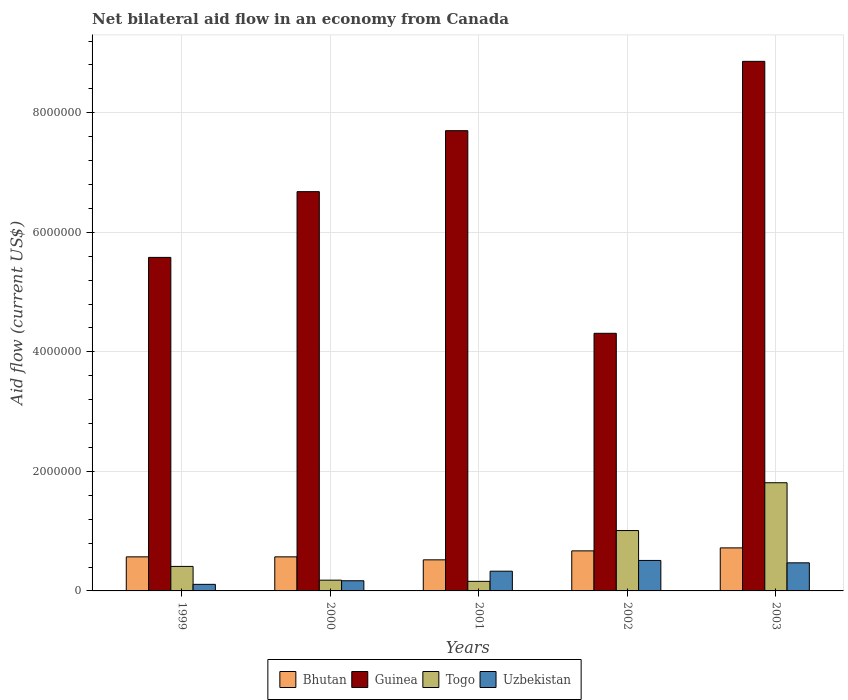How many groups of bars are there?
Offer a terse response. 5. What is the net bilateral aid flow in Bhutan in 2003?
Give a very brief answer. 7.20e+05. Across all years, what is the maximum net bilateral aid flow in Bhutan?
Keep it short and to the point. 7.20e+05. In which year was the net bilateral aid flow in Guinea maximum?
Keep it short and to the point. 2003. What is the total net bilateral aid flow in Guinea in the graph?
Provide a short and direct response. 3.31e+07. What is the difference between the net bilateral aid flow in Bhutan in 1999 and that in 2003?
Keep it short and to the point. -1.50e+05. What is the difference between the net bilateral aid flow in Guinea in 2003 and the net bilateral aid flow in Togo in 1999?
Make the answer very short. 8.45e+06. What is the average net bilateral aid flow in Guinea per year?
Offer a very short reply. 6.63e+06. In the year 2003, what is the difference between the net bilateral aid flow in Uzbekistan and net bilateral aid flow in Guinea?
Your response must be concise. -8.39e+06. In how many years, is the net bilateral aid flow in Guinea greater than 6400000 US$?
Keep it short and to the point. 3. What is the ratio of the net bilateral aid flow in Bhutan in 2000 to that in 2002?
Offer a terse response. 0.85. Is the difference between the net bilateral aid flow in Uzbekistan in 2002 and 2003 greater than the difference between the net bilateral aid flow in Guinea in 2002 and 2003?
Provide a short and direct response. Yes. What is the difference between the highest and the lowest net bilateral aid flow in Guinea?
Ensure brevity in your answer.  4.55e+06. In how many years, is the net bilateral aid flow in Togo greater than the average net bilateral aid flow in Togo taken over all years?
Offer a very short reply. 2. Is the sum of the net bilateral aid flow in Uzbekistan in 1999 and 2000 greater than the maximum net bilateral aid flow in Guinea across all years?
Offer a terse response. No. What does the 4th bar from the left in 2001 represents?
Offer a very short reply. Uzbekistan. What does the 1st bar from the right in 1999 represents?
Keep it short and to the point. Uzbekistan. Is it the case that in every year, the sum of the net bilateral aid flow in Bhutan and net bilateral aid flow in Togo is greater than the net bilateral aid flow in Uzbekistan?
Offer a terse response. Yes. Are all the bars in the graph horizontal?
Your answer should be very brief. No. How many years are there in the graph?
Keep it short and to the point. 5. What is the difference between two consecutive major ticks on the Y-axis?
Your answer should be compact. 2.00e+06. What is the title of the graph?
Your answer should be compact. Net bilateral aid flow in an economy from Canada. What is the Aid flow (current US$) in Bhutan in 1999?
Offer a terse response. 5.70e+05. What is the Aid flow (current US$) in Guinea in 1999?
Your response must be concise. 5.58e+06. What is the Aid flow (current US$) of Bhutan in 2000?
Your response must be concise. 5.70e+05. What is the Aid flow (current US$) of Guinea in 2000?
Provide a succinct answer. 6.68e+06. What is the Aid flow (current US$) in Togo in 2000?
Keep it short and to the point. 1.80e+05. What is the Aid flow (current US$) in Uzbekistan in 2000?
Give a very brief answer. 1.70e+05. What is the Aid flow (current US$) in Bhutan in 2001?
Your answer should be very brief. 5.20e+05. What is the Aid flow (current US$) of Guinea in 2001?
Offer a very short reply. 7.70e+06. What is the Aid flow (current US$) of Togo in 2001?
Offer a very short reply. 1.60e+05. What is the Aid flow (current US$) in Uzbekistan in 2001?
Provide a succinct answer. 3.30e+05. What is the Aid flow (current US$) of Bhutan in 2002?
Offer a very short reply. 6.70e+05. What is the Aid flow (current US$) in Guinea in 2002?
Offer a very short reply. 4.31e+06. What is the Aid flow (current US$) of Togo in 2002?
Make the answer very short. 1.01e+06. What is the Aid flow (current US$) of Uzbekistan in 2002?
Give a very brief answer. 5.10e+05. What is the Aid flow (current US$) of Bhutan in 2003?
Provide a short and direct response. 7.20e+05. What is the Aid flow (current US$) in Guinea in 2003?
Make the answer very short. 8.86e+06. What is the Aid flow (current US$) in Togo in 2003?
Your response must be concise. 1.81e+06. What is the Aid flow (current US$) in Uzbekistan in 2003?
Offer a very short reply. 4.70e+05. Across all years, what is the maximum Aid flow (current US$) in Bhutan?
Provide a short and direct response. 7.20e+05. Across all years, what is the maximum Aid flow (current US$) of Guinea?
Your response must be concise. 8.86e+06. Across all years, what is the maximum Aid flow (current US$) in Togo?
Provide a short and direct response. 1.81e+06. Across all years, what is the maximum Aid flow (current US$) of Uzbekistan?
Keep it short and to the point. 5.10e+05. Across all years, what is the minimum Aid flow (current US$) of Bhutan?
Give a very brief answer. 5.20e+05. Across all years, what is the minimum Aid flow (current US$) in Guinea?
Give a very brief answer. 4.31e+06. What is the total Aid flow (current US$) in Bhutan in the graph?
Provide a short and direct response. 3.05e+06. What is the total Aid flow (current US$) of Guinea in the graph?
Offer a terse response. 3.31e+07. What is the total Aid flow (current US$) in Togo in the graph?
Make the answer very short. 3.57e+06. What is the total Aid flow (current US$) of Uzbekistan in the graph?
Your answer should be very brief. 1.59e+06. What is the difference between the Aid flow (current US$) of Guinea in 1999 and that in 2000?
Offer a very short reply. -1.10e+06. What is the difference between the Aid flow (current US$) in Togo in 1999 and that in 2000?
Give a very brief answer. 2.30e+05. What is the difference between the Aid flow (current US$) in Guinea in 1999 and that in 2001?
Offer a very short reply. -2.12e+06. What is the difference between the Aid flow (current US$) of Togo in 1999 and that in 2001?
Ensure brevity in your answer.  2.50e+05. What is the difference between the Aid flow (current US$) of Guinea in 1999 and that in 2002?
Make the answer very short. 1.27e+06. What is the difference between the Aid flow (current US$) in Togo in 1999 and that in 2002?
Your answer should be compact. -6.00e+05. What is the difference between the Aid flow (current US$) in Uzbekistan in 1999 and that in 2002?
Your answer should be very brief. -4.00e+05. What is the difference between the Aid flow (current US$) of Bhutan in 1999 and that in 2003?
Keep it short and to the point. -1.50e+05. What is the difference between the Aid flow (current US$) in Guinea in 1999 and that in 2003?
Offer a very short reply. -3.28e+06. What is the difference between the Aid flow (current US$) in Togo in 1999 and that in 2003?
Keep it short and to the point. -1.40e+06. What is the difference between the Aid flow (current US$) of Uzbekistan in 1999 and that in 2003?
Offer a terse response. -3.60e+05. What is the difference between the Aid flow (current US$) in Bhutan in 2000 and that in 2001?
Ensure brevity in your answer.  5.00e+04. What is the difference between the Aid flow (current US$) of Guinea in 2000 and that in 2001?
Keep it short and to the point. -1.02e+06. What is the difference between the Aid flow (current US$) of Guinea in 2000 and that in 2002?
Provide a short and direct response. 2.37e+06. What is the difference between the Aid flow (current US$) of Togo in 2000 and that in 2002?
Your response must be concise. -8.30e+05. What is the difference between the Aid flow (current US$) of Uzbekistan in 2000 and that in 2002?
Offer a terse response. -3.40e+05. What is the difference between the Aid flow (current US$) in Guinea in 2000 and that in 2003?
Keep it short and to the point. -2.18e+06. What is the difference between the Aid flow (current US$) of Togo in 2000 and that in 2003?
Offer a very short reply. -1.63e+06. What is the difference between the Aid flow (current US$) of Uzbekistan in 2000 and that in 2003?
Offer a very short reply. -3.00e+05. What is the difference between the Aid flow (current US$) in Bhutan in 2001 and that in 2002?
Keep it short and to the point. -1.50e+05. What is the difference between the Aid flow (current US$) in Guinea in 2001 and that in 2002?
Your answer should be very brief. 3.39e+06. What is the difference between the Aid flow (current US$) of Togo in 2001 and that in 2002?
Your answer should be compact. -8.50e+05. What is the difference between the Aid flow (current US$) in Uzbekistan in 2001 and that in 2002?
Make the answer very short. -1.80e+05. What is the difference between the Aid flow (current US$) of Guinea in 2001 and that in 2003?
Make the answer very short. -1.16e+06. What is the difference between the Aid flow (current US$) in Togo in 2001 and that in 2003?
Offer a terse response. -1.65e+06. What is the difference between the Aid flow (current US$) of Uzbekistan in 2001 and that in 2003?
Ensure brevity in your answer.  -1.40e+05. What is the difference between the Aid flow (current US$) in Guinea in 2002 and that in 2003?
Your response must be concise. -4.55e+06. What is the difference between the Aid flow (current US$) of Togo in 2002 and that in 2003?
Your answer should be very brief. -8.00e+05. What is the difference between the Aid flow (current US$) in Bhutan in 1999 and the Aid flow (current US$) in Guinea in 2000?
Give a very brief answer. -6.11e+06. What is the difference between the Aid flow (current US$) in Bhutan in 1999 and the Aid flow (current US$) in Togo in 2000?
Your answer should be very brief. 3.90e+05. What is the difference between the Aid flow (current US$) of Bhutan in 1999 and the Aid flow (current US$) of Uzbekistan in 2000?
Your answer should be compact. 4.00e+05. What is the difference between the Aid flow (current US$) in Guinea in 1999 and the Aid flow (current US$) in Togo in 2000?
Your answer should be compact. 5.40e+06. What is the difference between the Aid flow (current US$) of Guinea in 1999 and the Aid flow (current US$) of Uzbekistan in 2000?
Give a very brief answer. 5.41e+06. What is the difference between the Aid flow (current US$) in Togo in 1999 and the Aid flow (current US$) in Uzbekistan in 2000?
Provide a succinct answer. 2.40e+05. What is the difference between the Aid flow (current US$) in Bhutan in 1999 and the Aid flow (current US$) in Guinea in 2001?
Your response must be concise. -7.13e+06. What is the difference between the Aid flow (current US$) in Bhutan in 1999 and the Aid flow (current US$) in Uzbekistan in 2001?
Provide a short and direct response. 2.40e+05. What is the difference between the Aid flow (current US$) in Guinea in 1999 and the Aid flow (current US$) in Togo in 2001?
Your answer should be very brief. 5.42e+06. What is the difference between the Aid flow (current US$) in Guinea in 1999 and the Aid flow (current US$) in Uzbekistan in 2001?
Offer a very short reply. 5.25e+06. What is the difference between the Aid flow (current US$) in Togo in 1999 and the Aid flow (current US$) in Uzbekistan in 2001?
Ensure brevity in your answer.  8.00e+04. What is the difference between the Aid flow (current US$) in Bhutan in 1999 and the Aid flow (current US$) in Guinea in 2002?
Your answer should be very brief. -3.74e+06. What is the difference between the Aid flow (current US$) in Bhutan in 1999 and the Aid flow (current US$) in Togo in 2002?
Your response must be concise. -4.40e+05. What is the difference between the Aid flow (current US$) in Guinea in 1999 and the Aid flow (current US$) in Togo in 2002?
Your answer should be very brief. 4.57e+06. What is the difference between the Aid flow (current US$) of Guinea in 1999 and the Aid flow (current US$) of Uzbekistan in 2002?
Offer a very short reply. 5.07e+06. What is the difference between the Aid flow (current US$) in Bhutan in 1999 and the Aid flow (current US$) in Guinea in 2003?
Offer a terse response. -8.29e+06. What is the difference between the Aid flow (current US$) in Bhutan in 1999 and the Aid flow (current US$) in Togo in 2003?
Offer a terse response. -1.24e+06. What is the difference between the Aid flow (current US$) in Guinea in 1999 and the Aid flow (current US$) in Togo in 2003?
Provide a short and direct response. 3.77e+06. What is the difference between the Aid flow (current US$) of Guinea in 1999 and the Aid flow (current US$) of Uzbekistan in 2003?
Offer a very short reply. 5.11e+06. What is the difference between the Aid flow (current US$) in Togo in 1999 and the Aid flow (current US$) in Uzbekistan in 2003?
Your answer should be very brief. -6.00e+04. What is the difference between the Aid flow (current US$) of Bhutan in 2000 and the Aid flow (current US$) of Guinea in 2001?
Give a very brief answer. -7.13e+06. What is the difference between the Aid flow (current US$) in Bhutan in 2000 and the Aid flow (current US$) in Togo in 2001?
Offer a terse response. 4.10e+05. What is the difference between the Aid flow (current US$) in Bhutan in 2000 and the Aid flow (current US$) in Uzbekistan in 2001?
Provide a short and direct response. 2.40e+05. What is the difference between the Aid flow (current US$) of Guinea in 2000 and the Aid flow (current US$) of Togo in 2001?
Your response must be concise. 6.52e+06. What is the difference between the Aid flow (current US$) in Guinea in 2000 and the Aid flow (current US$) in Uzbekistan in 2001?
Offer a very short reply. 6.35e+06. What is the difference between the Aid flow (current US$) of Togo in 2000 and the Aid flow (current US$) of Uzbekistan in 2001?
Offer a terse response. -1.50e+05. What is the difference between the Aid flow (current US$) in Bhutan in 2000 and the Aid flow (current US$) in Guinea in 2002?
Keep it short and to the point. -3.74e+06. What is the difference between the Aid flow (current US$) in Bhutan in 2000 and the Aid flow (current US$) in Togo in 2002?
Your answer should be very brief. -4.40e+05. What is the difference between the Aid flow (current US$) of Bhutan in 2000 and the Aid flow (current US$) of Uzbekistan in 2002?
Offer a terse response. 6.00e+04. What is the difference between the Aid flow (current US$) of Guinea in 2000 and the Aid flow (current US$) of Togo in 2002?
Make the answer very short. 5.67e+06. What is the difference between the Aid flow (current US$) in Guinea in 2000 and the Aid flow (current US$) in Uzbekistan in 2002?
Give a very brief answer. 6.17e+06. What is the difference between the Aid flow (current US$) of Togo in 2000 and the Aid flow (current US$) of Uzbekistan in 2002?
Your answer should be very brief. -3.30e+05. What is the difference between the Aid flow (current US$) of Bhutan in 2000 and the Aid flow (current US$) of Guinea in 2003?
Give a very brief answer. -8.29e+06. What is the difference between the Aid flow (current US$) in Bhutan in 2000 and the Aid flow (current US$) in Togo in 2003?
Make the answer very short. -1.24e+06. What is the difference between the Aid flow (current US$) in Guinea in 2000 and the Aid flow (current US$) in Togo in 2003?
Give a very brief answer. 4.87e+06. What is the difference between the Aid flow (current US$) in Guinea in 2000 and the Aid flow (current US$) in Uzbekistan in 2003?
Offer a terse response. 6.21e+06. What is the difference between the Aid flow (current US$) of Bhutan in 2001 and the Aid flow (current US$) of Guinea in 2002?
Your answer should be very brief. -3.79e+06. What is the difference between the Aid flow (current US$) in Bhutan in 2001 and the Aid flow (current US$) in Togo in 2002?
Ensure brevity in your answer.  -4.90e+05. What is the difference between the Aid flow (current US$) in Guinea in 2001 and the Aid flow (current US$) in Togo in 2002?
Provide a short and direct response. 6.69e+06. What is the difference between the Aid flow (current US$) of Guinea in 2001 and the Aid flow (current US$) of Uzbekistan in 2002?
Give a very brief answer. 7.19e+06. What is the difference between the Aid flow (current US$) of Togo in 2001 and the Aid flow (current US$) of Uzbekistan in 2002?
Provide a succinct answer. -3.50e+05. What is the difference between the Aid flow (current US$) in Bhutan in 2001 and the Aid flow (current US$) in Guinea in 2003?
Provide a short and direct response. -8.34e+06. What is the difference between the Aid flow (current US$) in Bhutan in 2001 and the Aid flow (current US$) in Togo in 2003?
Make the answer very short. -1.29e+06. What is the difference between the Aid flow (current US$) in Bhutan in 2001 and the Aid flow (current US$) in Uzbekistan in 2003?
Your response must be concise. 5.00e+04. What is the difference between the Aid flow (current US$) of Guinea in 2001 and the Aid flow (current US$) of Togo in 2003?
Make the answer very short. 5.89e+06. What is the difference between the Aid flow (current US$) of Guinea in 2001 and the Aid flow (current US$) of Uzbekistan in 2003?
Offer a terse response. 7.23e+06. What is the difference between the Aid flow (current US$) of Togo in 2001 and the Aid flow (current US$) of Uzbekistan in 2003?
Provide a short and direct response. -3.10e+05. What is the difference between the Aid flow (current US$) in Bhutan in 2002 and the Aid flow (current US$) in Guinea in 2003?
Offer a very short reply. -8.19e+06. What is the difference between the Aid flow (current US$) in Bhutan in 2002 and the Aid flow (current US$) in Togo in 2003?
Offer a terse response. -1.14e+06. What is the difference between the Aid flow (current US$) in Bhutan in 2002 and the Aid flow (current US$) in Uzbekistan in 2003?
Offer a very short reply. 2.00e+05. What is the difference between the Aid flow (current US$) in Guinea in 2002 and the Aid flow (current US$) in Togo in 2003?
Keep it short and to the point. 2.50e+06. What is the difference between the Aid flow (current US$) in Guinea in 2002 and the Aid flow (current US$) in Uzbekistan in 2003?
Give a very brief answer. 3.84e+06. What is the difference between the Aid flow (current US$) of Togo in 2002 and the Aid flow (current US$) of Uzbekistan in 2003?
Provide a short and direct response. 5.40e+05. What is the average Aid flow (current US$) of Guinea per year?
Provide a succinct answer. 6.63e+06. What is the average Aid flow (current US$) in Togo per year?
Make the answer very short. 7.14e+05. What is the average Aid flow (current US$) in Uzbekistan per year?
Offer a terse response. 3.18e+05. In the year 1999, what is the difference between the Aid flow (current US$) of Bhutan and Aid flow (current US$) of Guinea?
Offer a terse response. -5.01e+06. In the year 1999, what is the difference between the Aid flow (current US$) in Guinea and Aid flow (current US$) in Togo?
Ensure brevity in your answer.  5.17e+06. In the year 1999, what is the difference between the Aid flow (current US$) in Guinea and Aid flow (current US$) in Uzbekistan?
Make the answer very short. 5.47e+06. In the year 1999, what is the difference between the Aid flow (current US$) in Togo and Aid flow (current US$) in Uzbekistan?
Your answer should be compact. 3.00e+05. In the year 2000, what is the difference between the Aid flow (current US$) in Bhutan and Aid flow (current US$) in Guinea?
Keep it short and to the point. -6.11e+06. In the year 2000, what is the difference between the Aid flow (current US$) in Bhutan and Aid flow (current US$) in Uzbekistan?
Provide a succinct answer. 4.00e+05. In the year 2000, what is the difference between the Aid flow (current US$) of Guinea and Aid flow (current US$) of Togo?
Offer a terse response. 6.50e+06. In the year 2000, what is the difference between the Aid flow (current US$) in Guinea and Aid flow (current US$) in Uzbekistan?
Your answer should be compact. 6.51e+06. In the year 2001, what is the difference between the Aid flow (current US$) of Bhutan and Aid flow (current US$) of Guinea?
Ensure brevity in your answer.  -7.18e+06. In the year 2001, what is the difference between the Aid flow (current US$) in Bhutan and Aid flow (current US$) in Togo?
Provide a short and direct response. 3.60e+05. In the year 2001, what is the difference between the Aid flow (current US$) in Bhutan and Aid flow (current US$) in Uzbekistan?
Provide a succinct answer. 1.90e+05. In the year 2001, what is the difference between the Aid flow (current US$) of Guinea and Aid flow (current US$) of Togo?
Your answer should be very brief. 7.54e+06. In the year 2001, what is the difference between the Aid flow (current US$) in Guinea and Aid flow (current US$) in Uzbekistan?
Provide a short and direct response. 7.37e+06. In the year 2002, what is the difference between the Aid flow (current US$) in Bhutan and Aid flow (current US$) in Guinea?
Your answer should be very brief. -3.64e+06. In the year 2002, what is the difference between the Aid flow (current US$) in Guinea and Aid flow (current US$) in Togo?
Your answer should be very brief. 3.30e+06. In the year 2002, what is the difference between the Aid flow (current US$) of Guinea and Aid flow (current US$) of Uzbekistan?
Make the answer very short. 3.80e+06. In the year 2002, what is the difference between the Aid flow (current US$) in Togo and Aid flow (current US$) in Uzbekistan?
Give a very brief answer. 5.00e+05. In the year 2003, what is the difference between the Aid flow (current US$) in Bhutan and Aid flow (current US$) in Guinea?
Provide a succinct answer. -8.14e+06. In the year 2003, what is the difference between the Aid flow (current US$) of Bhutan and Aid flow (current US$) of Togo?
Keep it short and to the point. -1.09e+06. In the year 2003, what is the difference between the Aid flow (current US$) in Bhutan and Aid flow (current US$) in Uzbekistan?
Make the answer very short. 2.50e+05. In the year 2003, what is the difference between the Aid flow (current US$) in Guinea and Aid flow (current US$) in Togo?
Your answer should be very brief. 7.05e+06. In the year 2003, what is the difference between the Aid flow (current US$) of Guinea and Aid flow (current US$) of Uzbekistan?
Your answer should be very brief. 8.39e+06. In the year 2003, what is the difference between the Aid flow (current US$) of Togo and Aid flow (current US$) of Uzbekistan?
Your response must be concise. 1.34e+06. What is the ratio of the Aid flow (current US$) of Bhutan in 1999 to that in 2000?
Your answer should be compact. 1. What is the ratio of the Aid flow (current US$) in Guinea in 1999 to that in 2000?
Offer a terse response. 0.84. What is the ratio of the Aid flow (current US$) of Togo in 1999 to that in 2000?
Keep it short and to the point. 2.28. What is the ratio of the Aid flow (current US$) of Uzbekistan in 1999 to that in 2000?
Your answer should be compact. 0.65. What is the ratio of the Aid flow (current US$) of Bhutan in 1999 to that in 2001?
Your response must be concise. 1.1. What is the ratio of the Aid flow (current US$) of Guinea in 1999 to that in 2001?
Make the answer very short. 0.72. What is the ratio of the Aid flow (current US$) in Togo in 1999 to that in 2001?
Offer a terse response. 2.56. What is the ratio of the Aid flow (current US$) in Bhutan in 1999 to that in 2002?
Your answer should be compact. 0.85. What is the ratio of the Aid flow (current US$) in Guinea in 1999 to that in 2002?
Your answer should be very brief. 1.29. What is the ratio of the Aid flow (current US$) in Togo in 1999 to that in 2002?
Your answer should be compact. 0.41. What is the ratio of the Aid flow (current US$) of Uzbekistan in 1999 to that in 2002?
Offer a very short reply. 0.22. What is the ratio of the Aid flow (current US$) of Bhutan in 1999 to that in 2003?
Give a very brief answer. 0.79. What is the ratio of the Aid flow (current US$) of Guinea in 1999 to that in 2003?
Provide a short and direct response. 0.63. What is the ratio of the Aid flow (current US$) in Togo in 1999 to that in 2003?
Keep it short and to the point. 0.23. What is the ratio of the Aid flow (current US$) of Uzbekistan in 1999 to that in 2003?
Your answer should be very brief. 0.23. What is the ratio of the Aid flow (current US$) in Bhutan in 2000 to that in 2001?
Your answer should be very brief. 1.1. What is the ratio of the Aid flow (current US$) in Guinea in 2000 to that in 2001?
Provide a short and direct response. 0.87. What is the ratio of the Aid flow (current US$) in Uzbekistan in 2000 to that in 2001?
Your response must be concise. 0.52. What is the ratio of the Aid flow (current US$) of Bhutan in 2000 to that in 2002?
Provide a succinct answer. 0.85. What is the ratio of the Aid flow (current US$) of Guinea in 2000 to that in 2002?
Make the answer very short. 1.55. What is the ratio of the Aid flow (current US$) in Togo in 2000 to that in 2002?
Offer a terse response. 0.18. What is the ratio of the Aid flow (current US$) in Bhutan in 2000 to that in 2003?
Your response must be concise. 0.79. What is the ratio of the Aid flow (current US$) of Guinea in 2000 to that in 2003?
Provide a short and direct response. 0.75. What is the ratio of the Aid flow (current US$) in Togo in 2000 to that in 2003?
Your answer should be very brief. 0.1. What is the ratio of the Aid flow (current US$) of Uzbekistan in 2000 to that in 2003?
Your response must be concise. 0.36. What is the ratio of the Aid flow (current US$) in Bhutan in 2001 to that in 2002?
Offer a terse response. 0.78. What is the ratio of the Aid flow (current US$) in Guinea in 2001 to that in 2002?
Keep it short and to the point. 1.79. What is the ratio of the Aid flow (current US$) of Togo in 2001 to that in 2002?
Provide a succinct answer. 0.16. What is the ratio of the Aid flow (current US$) of Uzbekistan in 2001 to that in 2002?
Provide a short and direct response. 0.65. What is the ratio of the Aid flow (current US$) of Bhutan in 2001 to that in 2003?
Give a very brief answer. 0.72. What is the ratio of the Aid flow (current US$) in Guinea in 2001 to that in 2003?
Provide a succinct answer. 0.87. What is the ratio of the Aid flow (current US$) of Togo in 2001 to that in 2003?
Your answer should be very brief. 0.09. What is the ratio of the Aid flow (current US$) of Uzbekistan in 2001 to that in 2003?
Keep it short and to the point. 0.7. What is the ratio of the Aid flow (current US$) of Bhutan in 2002 to that in 2003?
Your answer should be very brief. 0.93. What is the ratio of the Aid flow (current US$) of Guinea in 2002 to that in 2003?
Your answer should be compact. 0.49. What is the ratio of the Aid flow (current US$) in Togo in 2002 to that in 2003?
Keep it short and to the point. 0.56. What is the ratio of the Aid flow (current US$) of Uzbekistan in 2002 to that in 2003?
Keep it short and to the point. 1.09. What is the difference between the highest and the second highest Aid flow (current US$) in Bhutan?
Your answer should be very brief. 5.00e+04. What is the difference between the highest and the second highest Aid flow (current US$) of Guinea?
Provide a short and direct response. 1.16e+06. What is the difference between the highest and the second highest Aid flow (current US$) in Uzbekistan?
Give a very brief answer. 4.00e+04. What is the difference between the highest and the lowest Aid flow (current US$) in Guinea?
Offer a very short reply. 4.55e+06. What is the difference between the highest and the lowest Aid flow (current US$) in Togo?
Keep it short and to the point. 1.65e+06. What is the difference between the highest and the lowest Aid flow (current US$) in Uzbekistan?
Provide a succinct answer. 4.00e+05. 